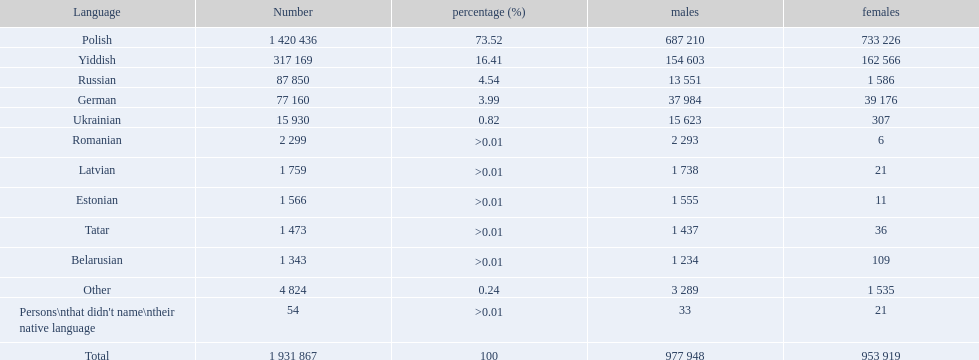What languages have a speaker count of above 50,000? Polish, Yiddish, Russian, German. Of those languages, which have less than 15% of the population speaking them? Russian, German. From the remaining two options, which language is spoken by 37,984 males? German. What are the languages spoken in the warsaw governorate? Polish, Yiddish, Russian, German, Ukrainian, Romanian, Latvian, Estonian, Tatar, Belarusian, Other, Persons\nthat didn't name\ntheir native language. What's the count for russian speakers? 87 850. What comes after the lowest number on the list? 77 160. Which language has 77,160 speakers? German. 